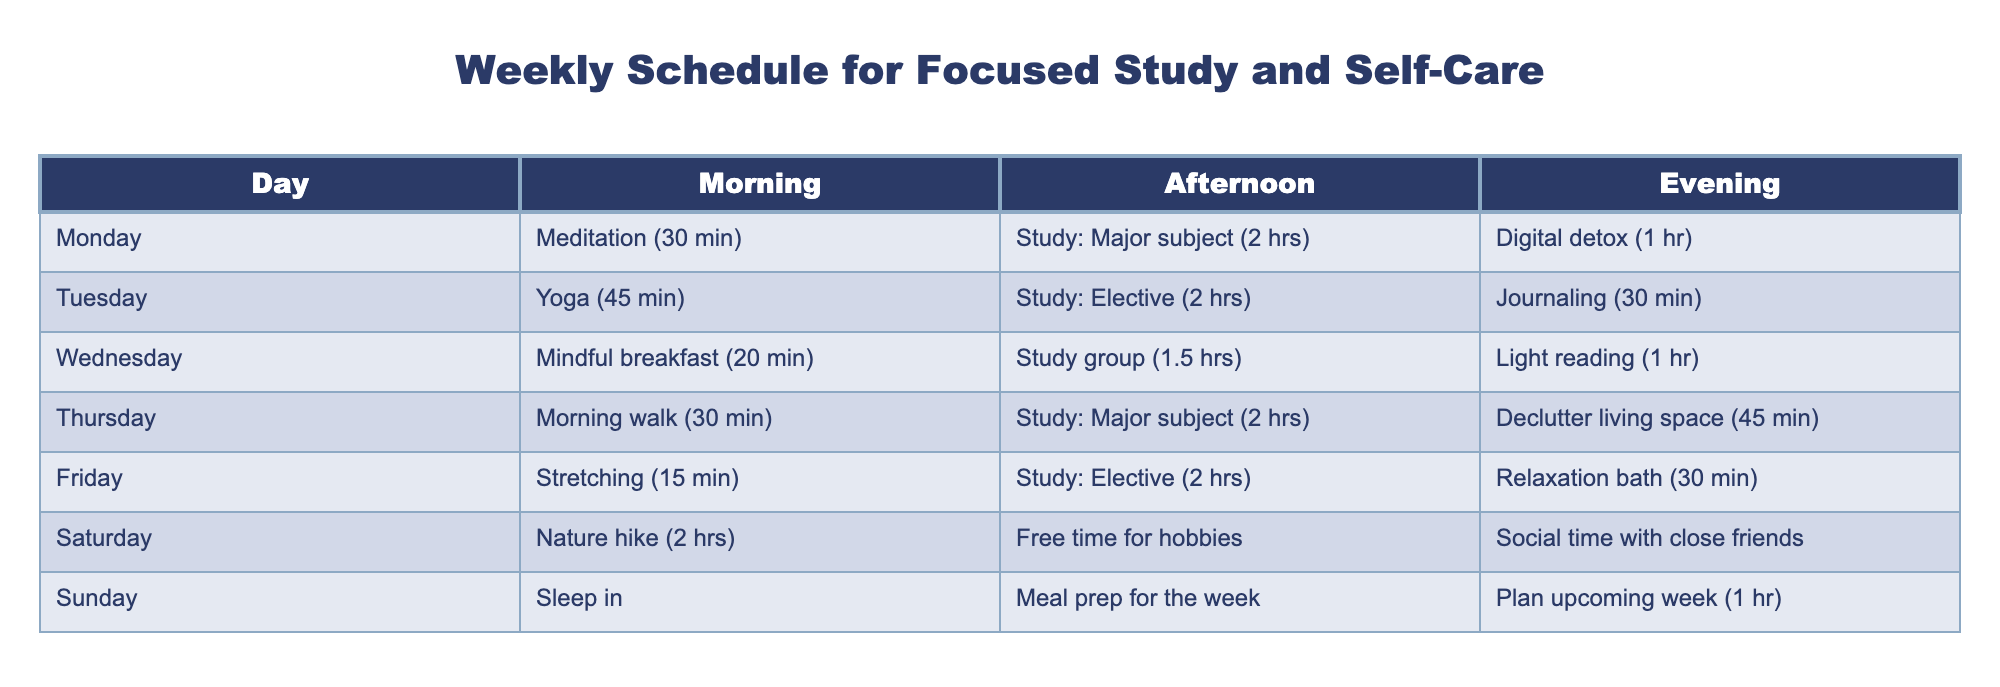What activity is scheduled for the evening on Tuesday? The table shows that on Tuesday, the scheduled activity for the evening is Journaling (30 min).
Answer: Journaling (30 min) On which day do you have the longest study session? Comparing the study durations across each day, both Monday and Tuesday have 2-hour sessions for major and elective subjects respectively. However, on Wednesday, there is a study group for 1.5 hours, which is less than the others. Therefore, Monday and Tuesday are the days with the longest study sessions.
Answer: Monday & Tuesday Is there a day designated for decluttering living space? Yes, according to the table, Thursday is the day set aside for decluttering living space (45 min).
Answer: Yes What is the total duration of study on Friday? On Friday, the study session is 2 hours for the elective subject. This is the only study activity scheduled for that day. Hence, the total study duration is just the 2 hours of study.
Answer: 2 hours Which day has a nature-related outdoor activity and how long does it last? Saturday is designated for a nature hike, which lasts for 2 hours, as indicated in the morning slot of that day.
Answer: Nature hike, 2 hours What percentage of the afternoons during the week are dedicated to study? There are 7 afternoons in a week. The study sessions take place on Monday, Tuesday, Wednesday, and Friday, totaling 4 study sessions. To find the percentage, divide 4 by 7 and multiply by 100, which gives approximately 57.14%.
Answer: Approximately 57.14% On which day is meditation practiced and how long is it? The table lists meditation on Monday for a duration of 30 minutes.
Answer: Monday, 30 minutes How does the average length of self-care activities compare to study activities throughout the week? First, we need to sum the durations of self-care activities: Meditation (30 min) + Yoga (45 min) + Mindful breakfast (20 min) + Morning walk (30 min) + Stretching (15 min) + Nature hike (120 min) + Sleep in (assumed to be like a self-care block). So, 30 + 45 + 20 + 30 + 15 + 120 + 0 = 260 minutes out of the week. Comparing this with study: 2 (Mon) + 2 (Tue) + 1.5 (Wed) + 2 (Thu) + 2 (Fri) = 10.5 hours or 630 minutes. The average for self-care per day is about 37.14 min while study is about 90 min. Self-care averages less than study durations.
Answer: Self-care avg is 37.14 min, study avg is 90 min Are all days accounted for in the schedule? Yes, the table provides activities listed for each day of the week, showing a complete schedule.
Answer: Yes 